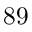Convert formula to latex. <formula><loc_0><loc_0><loc_500><loc_500>8 9</formula> 